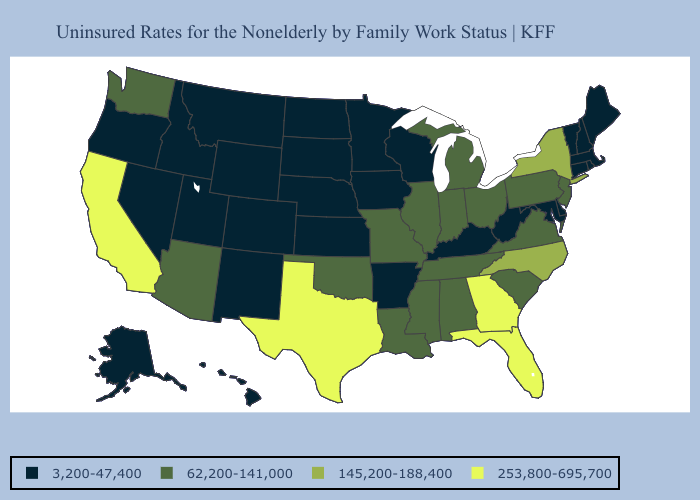What is the highest value in the USA?
Keep it brief. 253,800-695,700. Name the states that have a value in the range 253,800-695,700?
Quick response, please. California, Florida, Georgia, Texas. What is the highest value in states that border Rhode Island?
Keep it brief. 3,200-47,400. Name the states that have a value in the range 3,200-47,400?
Quick response, please. Alaska, Arkansas, Colorado, Connecticut, Delaware, Hawaii, Idaho, Iowa, Kansas, Kentucky, Maine, Maryland, Massachusetts, Minnesota, Montana, Nebraska, Nevada, New Hampshire, New Mexico, North Dakota, Oregon, Rhode Island, South Dakota, Utah, Vermont, West Virginia, Wisconsin, Wyoming. Does Maine have the lowest value in the Northeast?
Short answer required. Yes. Name the states that have a value in the range 145,200-188,400?
Concise answer only. New York, North Carolina. How many symbols are there in the legend?
Quick response, please. 4. Does California have the lowest value in the USA?
Give a very brief answer. No. Does Louisiana have a higher value than Maryland?
Concise answer only. Yes. What is the highest value in the USA?
Short answer required. 253,800-695,700. Name the states that have a value in the range 253,800-695,700?
Give a very brief answer. California, Florida, Georgia, Texas. What is the value of Georgia?
Concise answer only. 253,800-695,700. Does Massachusetts have a lower value than Indiana?
Be succinct. Yes. What is the value of Alabama?
Answer briefly. 62,200-141,000. What is the highest value in states that border Maryland?
Give a very brief answer. 62,200-141,000. 